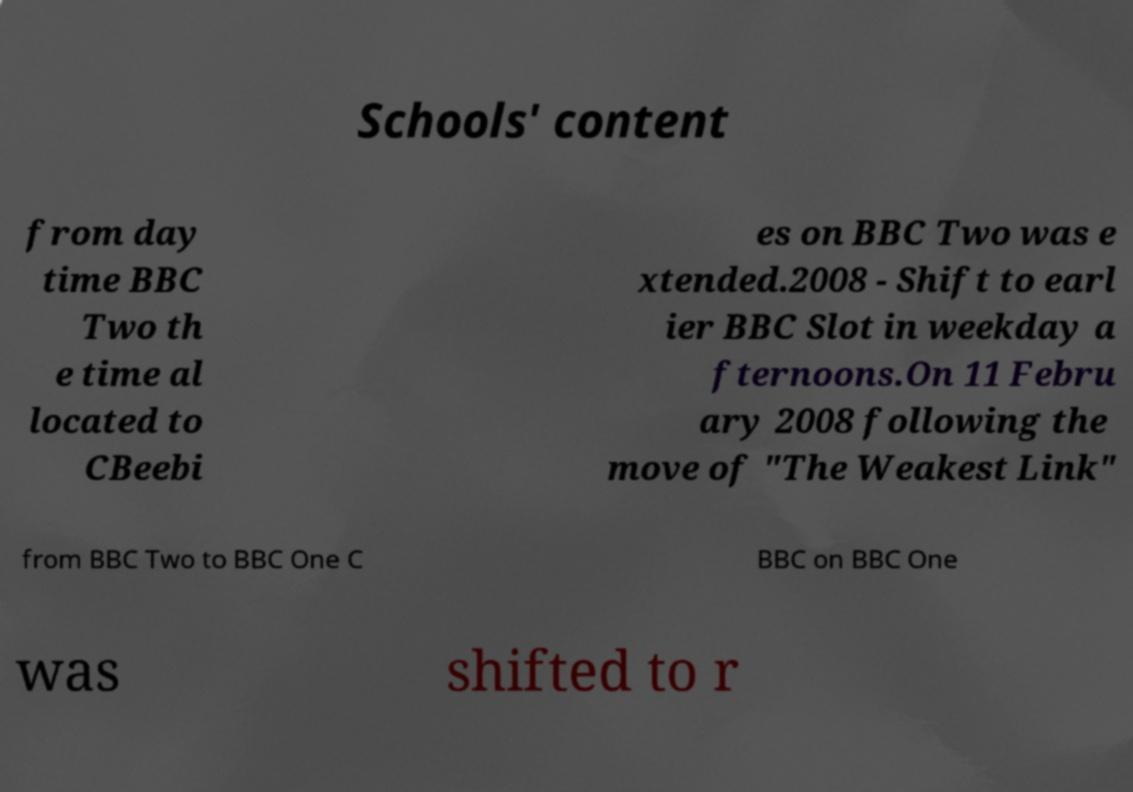Could you extract and type out the text from this image? Schools' content from day time BBC Two th e time al located to CBeebi es on BBC Two was e xtended.2008 - Shift to earl ier BBC Slot in weekday a fternoons.On 11 Febru ary 2008 following the move of "The Weakest Link" from BBC Two to BBC One C BBC on BBC One was shifted to r 